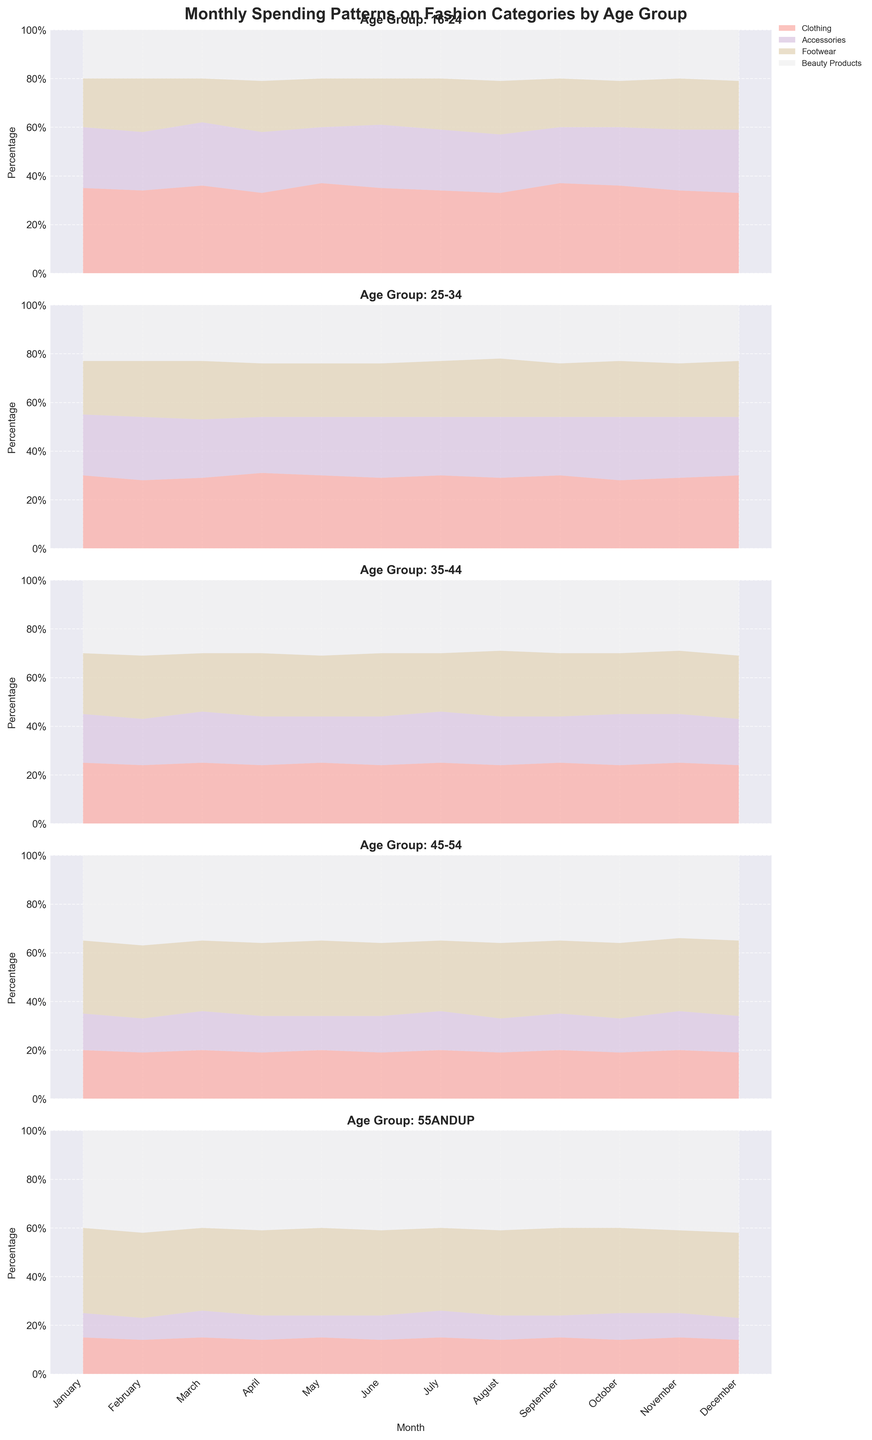How is the monthly spending pattern displayed in the figure? The monthly spending pattern is displayed using a 100% Stacked Area Chart, where the x-axis represents the months, and the y-axis represents the percentage distribution of spending across different fashion categories. Each age group has a separate plot, and different colors represent different categories like Clothing, Accessories, Footwear, and Beauty Products.
Answer: 100% Stacked Area Chart What month shows the highest percentage of spending on accessories for the age group 16-24? By examining the plot for the age group 16-24, the highest percentage of spending on Accessories appears in March, where the area for Accessories (represented by a specific color) is larger compared to other months.
Answer: March Which age group spends the highest percentage on beauty products in January? By looking at the January data for each age group, the age group 55 and up spends the highest percentage on beauty products. This is evident from the largest area segment for beauty products in their respective plot.
Answer: 55 and up In which month does the age group 25-34 spend the lowest percentage on Clothing? Upon reviewing the plot for the age group 25-34, February shows the lowest percentage of spending on Clothing as the proportion of the area taken up by this category is smallest during this month.
Answer: February Compare the spending patterns on footwear between the age groups 35-44 and 45-54 in December. Which group shows a higher percentage? The plot for December shows that the age group 45-54 has a higher percentage of spending on footwear compared to the age group 35-44. This can be seen as the footwear area segment is larger for 45-54 in December.
Answer: 45-54 Over the months, does the age group 16-24 have a consistent pattern in their spending on beauty products? Based on the plot, the age group 16-24 maintains a consistent spending pattern on beauty products, with percentages fluctuating very slightly around 20-21% throughout the months.
Answer: Yes What is the average monthly percentage spending on accessories by the age group 25-34? To find the average percentage spending on accessories for ages 25-34, sum the percentage values for each month and divide by the number of months. The sum is 24+26+24+23+24+25+24+25+24+26+25+24 = 294%, so the average is 294/12 ≈ 24.5%.
Answer: 24.5% During which month does the age group 55 and up spend the highest percentage on footwear? The plot shows that November has the highest percentage of spending on footwear for the age group 55 and up, as indicated by the largest segment size.
Answer: November How does the percentage of spending on clothing change from January to December for the age group 35-44? For the age group 35-44, the spending on clothing starts at 25% in January and shows minor fluctuations throughout the year, returning to 24% in December, thus showing little change over the year.
Answer: Little change 